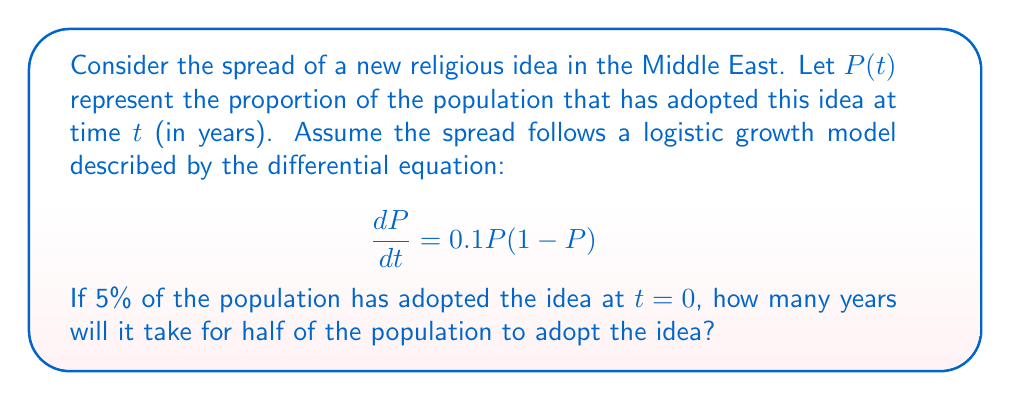Show me your answer to this math problem. To solve this problem, we need to follow these steps:

1) The logistic equation is given by:
   $$\frac{dP}{dt} = kP(1-P)$$
   where $k$ is the growth rate. In this case, $k = 0.1$.

2) The solution to this differential equation is:
   $$P(t) = \frac{1}{1 + Ce^{-kt}}$$
   where $C$ is a constant determined by the initial condition.

3) Given the initial condition $P(0) = 0.05$, we can find $C$:
   $$0.05 = \frac{1}{1 + C}$$
   $$C = \frac{1}{0.05} - 1 = 19$$

4) So our specific solution is:
   $$P(t) = \frac{1}{1 + 19e^{-0.1t}}$$

5) We want to find $t$ when $P(t) = 0.5$. Let's substitute this:
   $$0.5 = \frac{1}{1 + 19e^{-0.1t}}$$

6) Solving for $t$:
   $$1 + 19e^{-0.1t} = 2$$
   $$19e^{-0.1t} = 1$$
   $$e^{-0.1t} = \frac{1}{19}$$
   $$-0.1t = \ln(\frac{1}{19})$$
   $$t = -10\ln(\frac{1}{19}) \approx 29.66$$

Therefore, it will take approximately 29.66 years for half of the population to adopt the new religious idea.
Answer: Approximately 29.66 years 